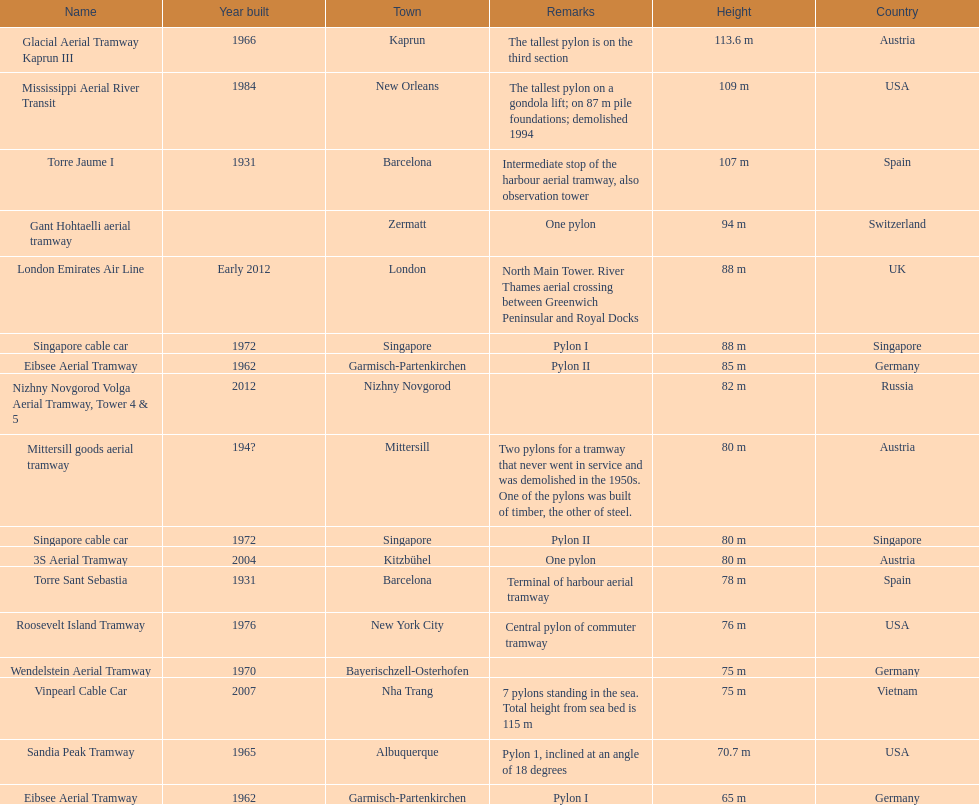Could you help me parse every detail presented in this table? {'header': ['Name', 'Year built', 'Town', 'Remarks', 'Height', 'Country'], 'rows': [['Glacial Aerial Tramway Kaprun III', '1966', 'Kaprun', 'The tallest pylon is on the third section', '113.6 m', 'Austria'], ['Mississippi Aerial River Transit', '1984', 'New Orleans', 'The tallest pylon on a gondola lift; on 87 m pile foundations; demolished 1994', '109 m', 'USA'], ['Torre Jaume I', '1931', 'Barcelona', 'Intermediate stop of the harbour aerial tramway, also observation tower', '107 m', 'Spain'], ['Gant Hohtaelli aerial tramway', '', 'Zermatt', 'One pylon', '94 m', 'Switzerland'], ['London Emirates Air Line', 'Early 2012', 'London', 'North Main Tower. River Thames aerial crossing between Greenwich Peninsular and Royal Docks', '88 m', 'UK'], ['Singapore cable car', '1972', 'Singapore', 'Pylon I', '88 m', 'Singapore'], ['Eibsee Aerial Tramway', '1962', 'Garmisch-Partenkirchen', 'Pylon II', '85 m', 'Germany'], ['Nizhny Novgorod Volga Aerial Tramway, Tower 4 & 5', '2012', 'Nizhny Novgorod', '', '82 m', 'Russia'], ['Mittersill goods aerial tramway', '194?', 'Mittersill', 'Two pylons for a tramway that never went in service and was demolished in the 1950s. One of the pylons was built of timber, the other of steel.', '80 m', 'Austria'], ['Singapore cable car', '1972', 'Singapore', 'Pylon II', '80 m', 'Singapore'], ['3S Aerial Tramway', '2004', 'Kitzbühel', 'One pylon', '80 m', 'Austria'], ['Torre Sant Sebastia', '1931', 'Barcelona', 'Terminal of harbour aerial tramway', '78 m', 'Spain'], ['Roosevelt Island Tramway', '1976', 'New York City', 'Central pylon of commuter tramway', '76 m', 'USA'], ['Wendelstein Aerial Tramway', '1970', 'Bayerischzell-Osterhofen', '', '75 m', 'Germany'], ['Vinpearl Cable Car', '2007', 'Nha Trang', '7 pylons standing in the sea. Total height from sea bed is 115 m', '75 m', 'Vietnam'], ['Sandia Peak Tramway', '1965', 'Albuquerque', 'Pylon 1, inclined at an angle of 18 degrees', '70.7 m', 'USA'], ['Eibsee Aerial Tramway', '1962', 'Garmisch-Partenkirchen', 'Pylon I', '65 m', 'Germany']]} Which pylon has the most remarks about it? Mittersill goods aerial tramway. 